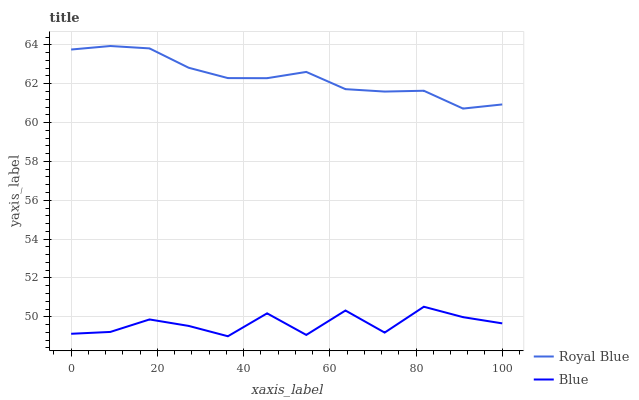Does Royal Blue have the minimum area under the curve?
Answer yes or no. No. Is Royal Blue the roughest?
Answer yes or no. No. Does Royal Blue have the lowest value?
Answer yes or no. No. Is Blue less than Royal Blue?
Answer yes or no. Yes. Is Royal Blue greater than Blue?
Answer yes or no. Yes. Does Blue intersect Royal Blue?
Answer yes or no. No. 